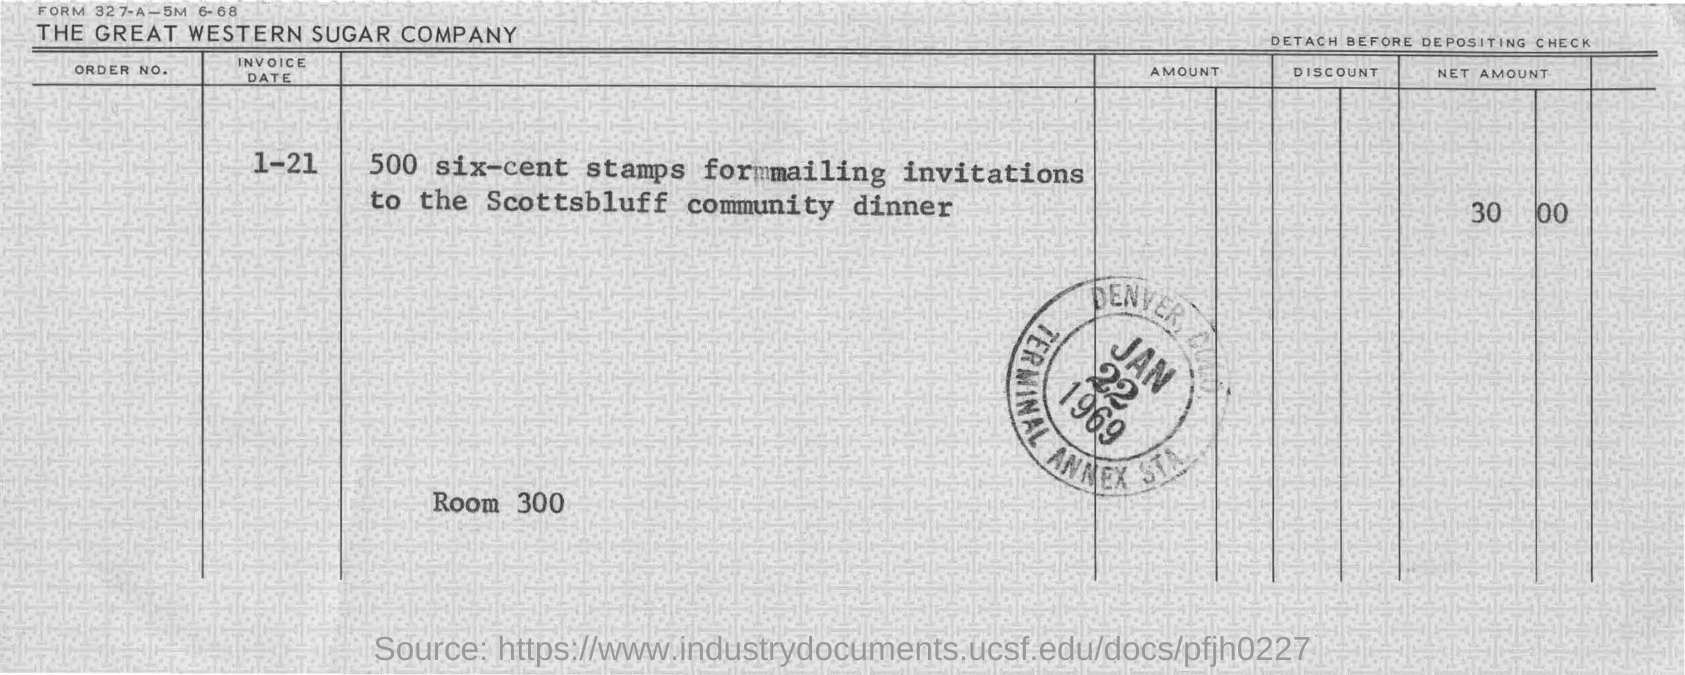What is the invoice date?
Ensure brevity in your answer.  1-21. When is the stamp dated?
Give a very brief answer. JAN 22 1969. For what should the invitations be mailed?
Offer a terse response. Scottsbluff community dinner. How many six-cent stamps are needed for mailing invitations?
Your response must be concise. 500. 